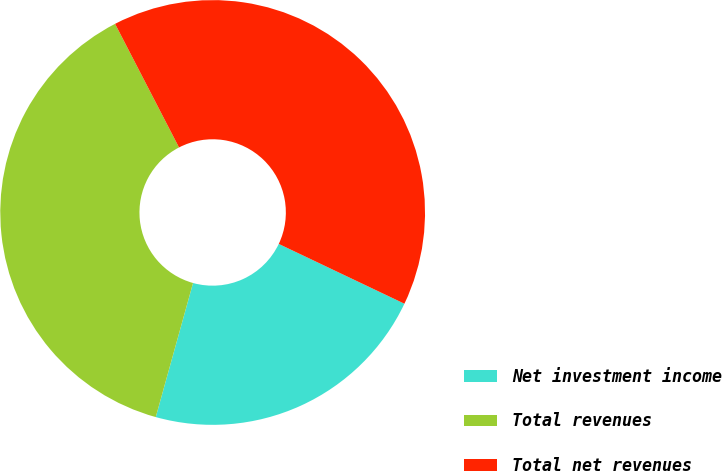<chart> <loc_0><loc_0><loc_500><loc_500><pie_chart><fcel>Net investment income<fcel>Total revenues<fcel>Total net revenues<nl><fcel>22.25%<fcel>38.09%<fcel>39.67%<nl></chart> 